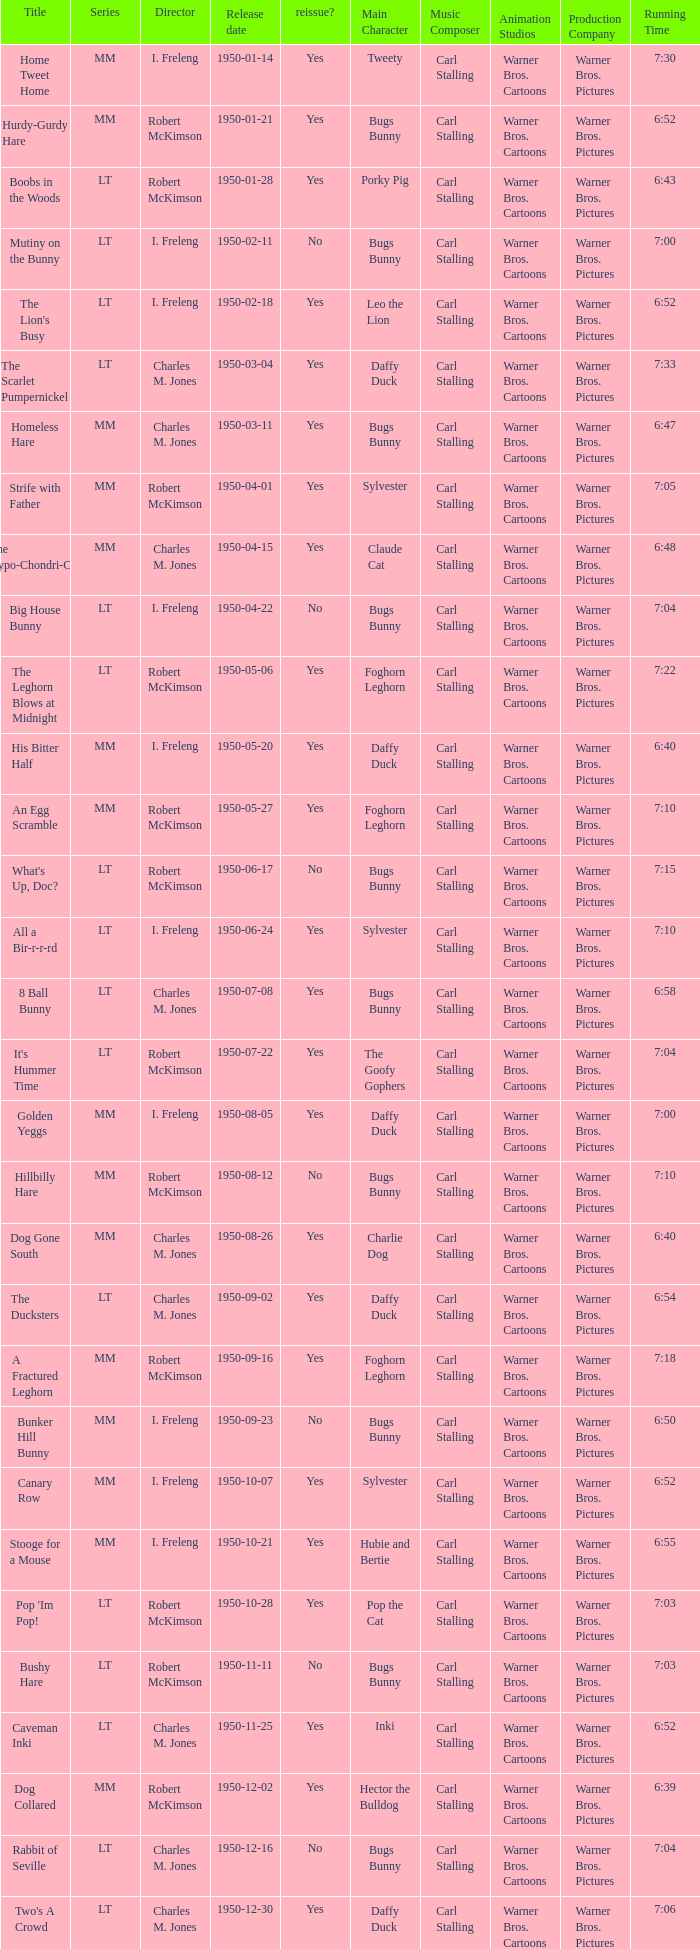Who directed Bunker Hill Bunny? I. Freleng. 